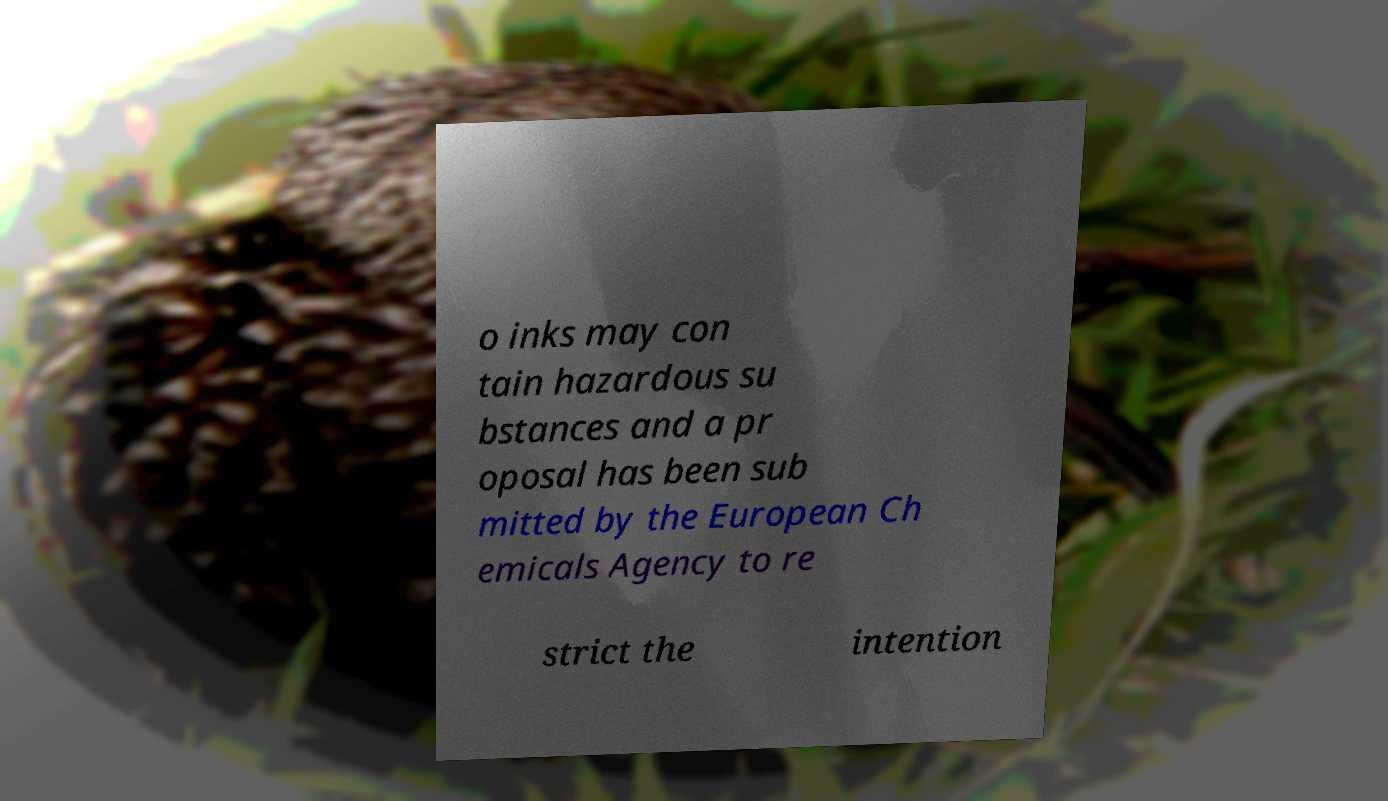I need the written content from this picture converted into text. Can you do that? o inks may con tain hazardous su bstances and a pr oposal has been sub mitted by the European Ch emicals Agency to re strict the intention 